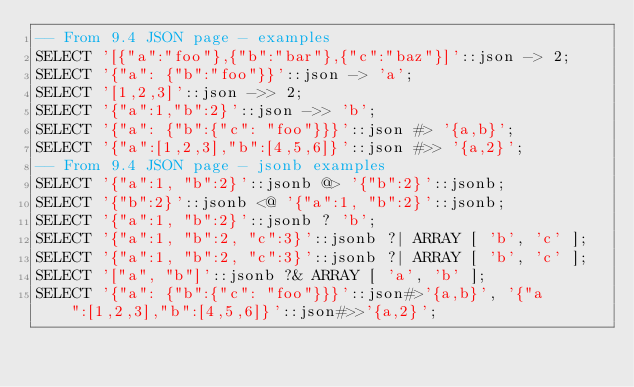Convert code to text. <code><loc_0><loc_0><loc_500><loc_500><_SQL_>-- From 9.4 JSON page - examples
SELECT '[{"a":"foo"},{"b":"bar"},{"c":"baz"}]'::json -> 2;
SELECT '{"a": {"b":"foo"}}'::json -> 'a';
SELECT '[1,2,3]'::json ->> 2;
SELECT '{"a":1,"b":2}'::json ->> 'b';
SELECT '{"a": {"b":{"c": "foo"}}}'::json #> '{a,b}';
SELECT '{"a":[1,2,3],"b":[4,5,6]}'::json #>> '{a,2}';
-- From 9.4 JSON page - jsonb examples
SELECT '{"a":1, "b":2}'::jsonb @> '{"b":2}'::jsonb;
SELECT '{"b":2}'::jsonb <@ '{"a":1, "b":2}'::jsonb;
SELECT '{"a":1, "b":2}'::jsonb ? 'b';
SELECT '{"a":1, "b":2, "c":3}'::jsonb ?| ARRAY [ 'b', 'c' ];
SELECT '{"a":1, "b":2, "c":3}'::jsonb ?| ARRAY [ 'b', 'c' ];
SELECT '["a", "b"]'::jsonb ?& ARRAY [ 'a', 'b' ];
SELECT '{"a": {"b":{"c": "foo"}}}'::json#>'{a,b}', '{"a":[1,2,3],"b":[4,5,6]}'::json#>>'{a,2}';
</code> 